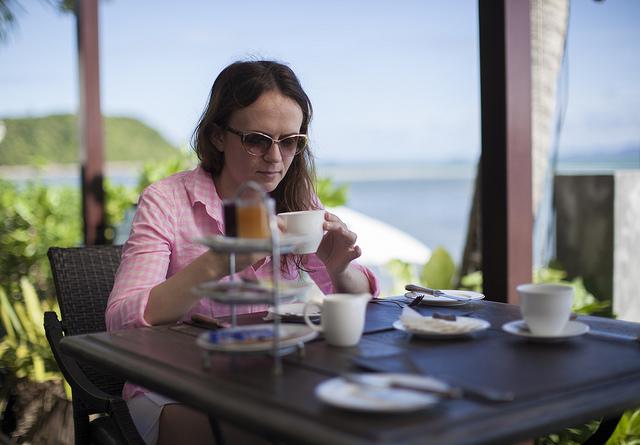What is the woman drinking?
Write a very short answer. Coffee. What color is the pink cup?
Answer briefly. Pink. What is the woman holding?
Be succinct. Cup. Are there enough napkins?
Be succinct. No. What is on her face?
Answer briefly. Sunglasses. Is she sitting alone?
Be succinct. Yes. 